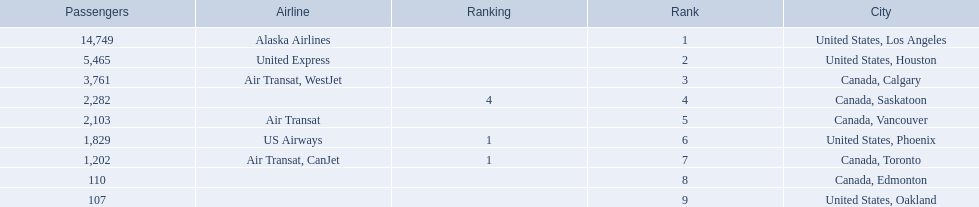Could you help me parse every detail presented in this table? {'header': ['Passengers', 'Airline', 'Ranking', 'Rank', 'City'], 'rows': [['14,749', 'Alaska Airlines', '', '1', 'United States, Los Angeles'], ['5,465', 'United Express', '', '2', 'United States, Houston'], ['3,761', 'Air Transat, WestJet', '', '3', 'Canada, Calgary'], ['2,282', '', '4', '4', 'Canada, Saskatoon'], ['2,103', 'Air Transat', '', '5', 'Canada, Vancouver'], ['1,829', 'US Airways', '1', '6', 'United States, Phoenix'], ['1,202', 'Air Transat, CanJet', '1', '7', 'Canada, Toronto'], ['110', '', '', '8', 'Canada, Edmonton'], ['107', '', '', '9', 'United States, Oakland']]} Which airport has the least amount of passengers? 107. What airport has 107 passengers? United States, Oakland. 